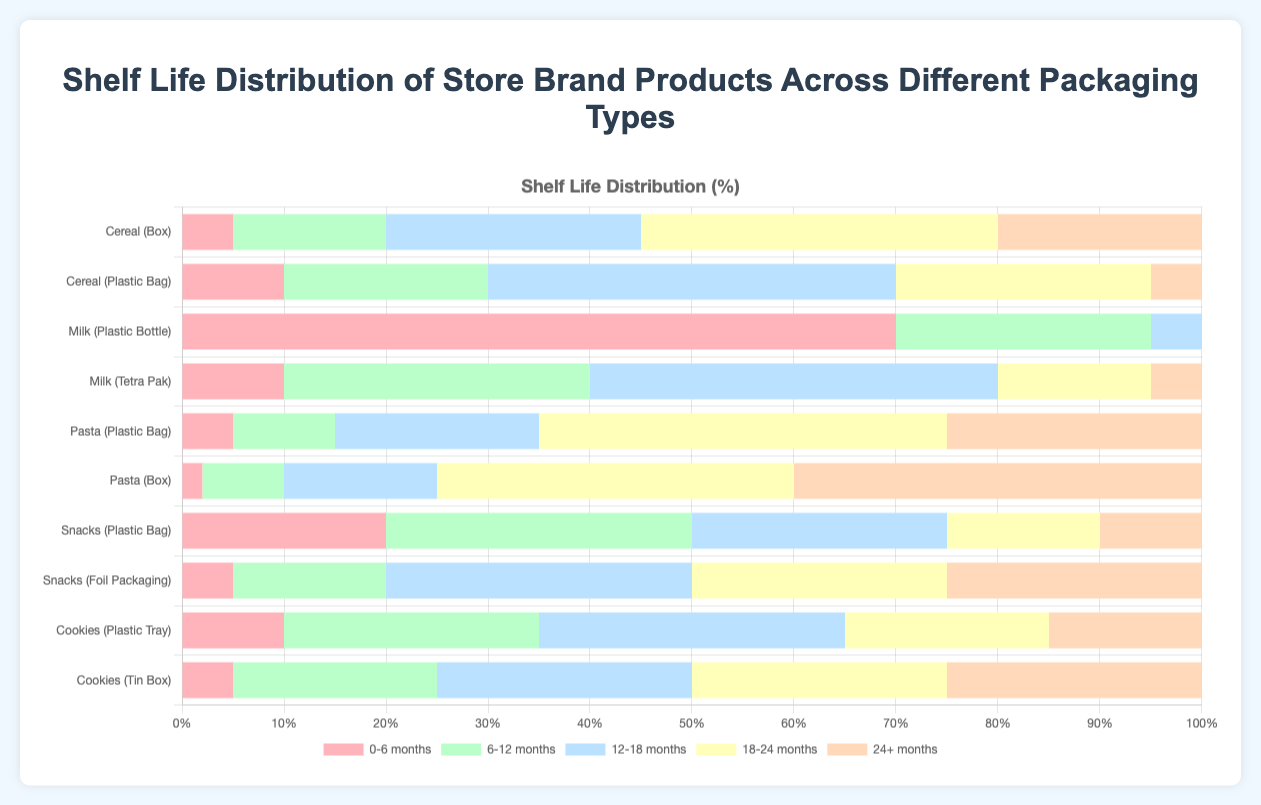What product and packaging type has the highest number of items with a 0-6 months shelf life? By referring to the figure, we identify the longest bar segment for the 0-6 months category, which is for Milk in Plastic Bottle.
Answer: Milk in Plastic Bottle Which product and packaging type has the longest shelf life distribution in the 24+ months category? Observing the longest bar segment in the 24+ months category, we see it for Pasta in Box.
Answer: Pasta in Box Compare the shelf life of Milk in Plastic Bottle and Milk in Tetra Pak. Which packaging provides a longer shelf life? By comparing the bar lengths, Milk in Tetra Pak has more items in the longer shelf life categories (12+ months) than Milk in Plastic Bottle.
Answer: Tetra Pak How does the total shelf life distribution compare between Cereal in Box and Cereal in Plastic Bag? Summing up the distributions for each category:
- Box: 5 + 15 + 25 + 35 + 20 = 100
- Plastic Bag: 10 + 20 + 40 + 25 + 5 = 100
Both types have the same total count of 100.
Answer: The same Which product and packaging has the least number of 24+ month shelf life items? By looking at the smallest segment in the 24+ months category, it's Cereal in Plastic Bag and Milk in Plastic Bottle, both with 5 items.
Answer: Cereal in Plastic Bag and Milk in Plastic Bottle Which product type has the widest variety in shelf life distribution? Sorting through the distribution bars, Pasta in Box shows the widest variety with significant segments in almost every category.
Answer: Pasta in Box For Snacks, compare the 0-6 months shelf life between Plastic Bag and Foil Packaging. Which one is greater? Referring to the segments, Snacks in Plastic Bag has a longer bar in the 0-6 months shelf life category than Foil Packaging.
Answer: Plastic Bag Considering the Cookies product, which packaging type provides a longer shelf life in the 18-24 months category? Among the Cookies product, Tin Box has a larger segment in the 18-24 months category than Plastic Tray.
Answer: Tin Box 